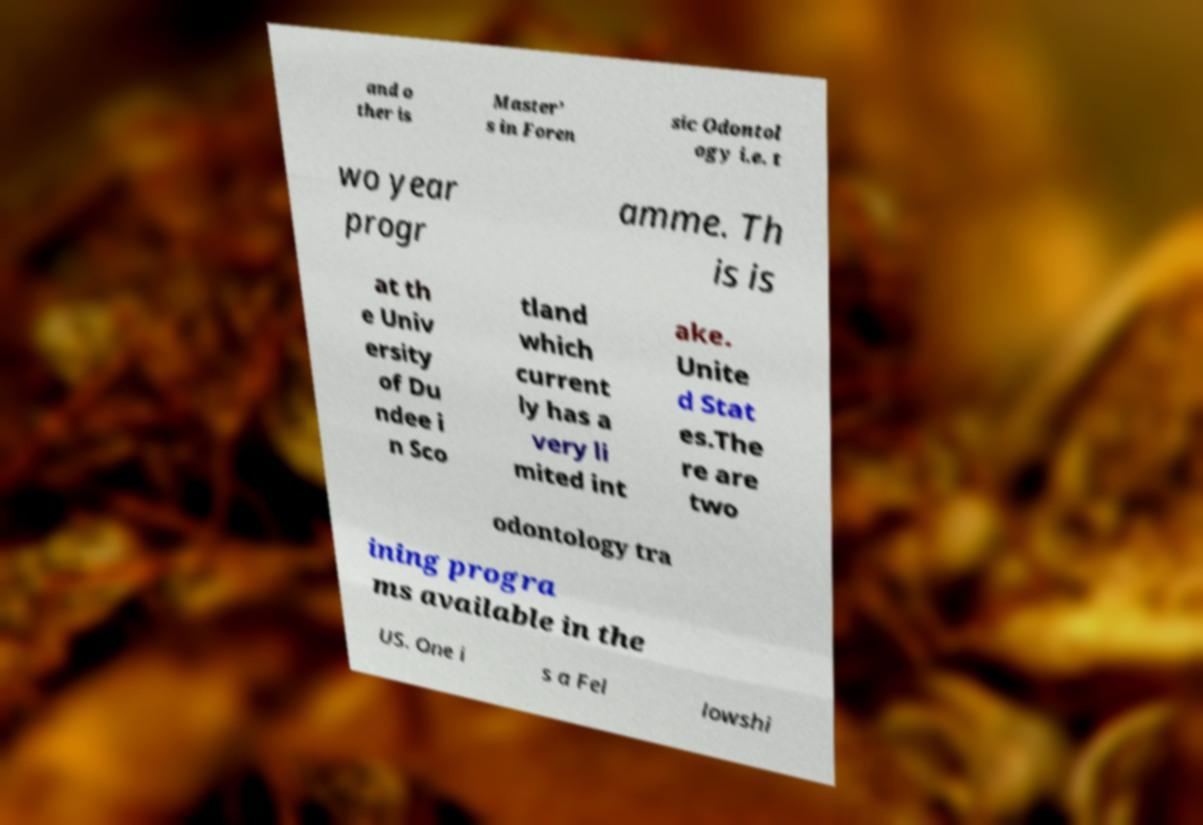Could you assist in decoding the text presented in this image and type it out clearly? and o ther is Master’ s in Foren sic Odontol ogy i.e. t wo year progr amme. Th is is at th e Univ ersity of Du ndee i n Sco tland which current ly has a very li mited int ake. Unite d Stat es.The re are two odontology tra ining progra ms available in the US. One i s a Fel lowshi 